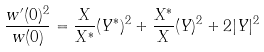Convert formula to latex. <formula><loc_0><loc_0><loc_500><loc_500>\frac { w ^ { \prime } ( 0 ) ^ { 2 } } { w ( 0 ) } = \frac { X } { X ^ { \ast } } ( Y ^ { \ast } ) ^ { 2 } + \frac { X ^ { \ast } } { X } ( Y ) ^ { 2 } + 2 | Y | ^ { 2 }</formula> 